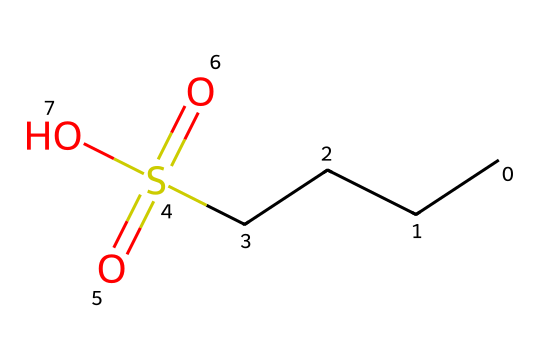What is the molecular formula of this compound? To find the molecular formula, count the number of each type of atom represented in the SMILES. The structure "CCCCS(=O)(=O)O" contains 4 carbon (C) atoms, 10 hydrogen (H) atoms, 1 sulfur (S) atom, and 3 oxygen (O) atoms. Putting these together, the molecular formula is C4H10O3S.
Answer: C4H10O3S How many oxygen atoms are present in this compound? The structure indicates three oxygen atoms attached to the sulfur atom (one in a hydroxyl group and two in sulfonyl groups). Therefore, the total count is three.
Answer: 3 What type of functional group is indicated by the "S(=O)(=O)" part of the SMILES? The presence of sulfur (S) bonded to two double-bonded oxygen atoms (O) indicates a sulfonyl functional group. This is a characteristic of sulfonic acids and their derivatives.
Answer: sulfonyl What is the role of the hydroxyl group (-OH) in this compound? The hydroxyl group provides polarity and solubility to the molecule, influencing its interaction with water and potentially enhancing the cleaning properties in guitar string cleaning compounds.
Answer: polarity and solubility Is this compound likely to be acidic, basic, or neutral? The presence of a sulfonic acid group (the −S(=O)(=O)O part) suggests that this compound can donate a proton (H+) in solution, indicating that it is acidic.
Answer: acidic How does the chain length (CCCC) affect the cleaning properties of this compound? Longer carbon chains can enhance the hydrocarbon solvent properties of a cleaning compound, aiding in the removal of grease and dirt from guitar strings, thus improving its cleaning performance.
Answer: improved cleaning performance 